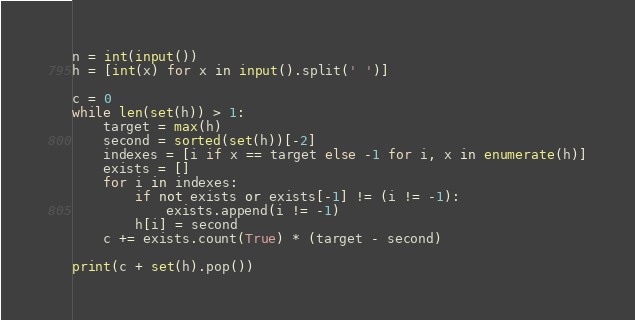<code> <loc_0><loc_0><loc_500><loc_500><_Python_>n = int(input())
h = [int(x) for x in input().split(' ')]

c = 0
while len(set(h)) > 1:
    target = max(h)
    second = sorted(set(h))[-2]
    indexes = [i if x == target else -1 for i, x in enumerate(h)]
    exists = []
    for i in indexes:
        if not exists or exists[-1] != (i != -1):
            exists.append(i != -1)
        h[i] = second
    c += exists.count(True) * (target - second)

print(c + set(h).pop())
</code> 